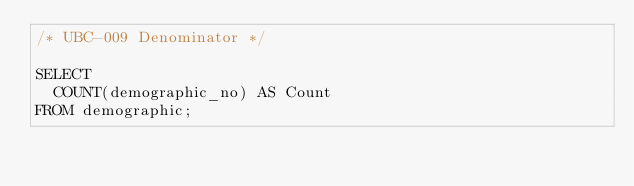Convert code to text. <code><loc_0><loc_0><loc_500><loc_500><_SQL_>/* UBC-009 Denominator */

SELECT
  COUNT(demographic_no) AS Count
FROM demographic;
</code> 